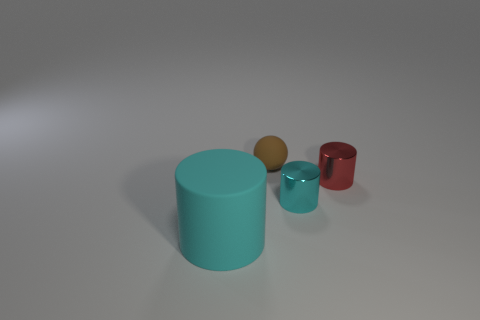Subtract all cyan cylinders. How many cylinders are left? 1 Subtract all red shiny cylinders. How many cylinders are left? 2 Subtract 0 purple cylinders. How many objects are left? 4 Subtract all cylinders. How many objects are left? 1 Subtract 3 cylinders. How many cylinders are left? 0 Subtract all cyan balls. Subtract all purple cylinders. How many balls are left? 1 Subtract all yellow cubes. How many red cylinders are left? 1 Subtract all large cyan matte balls. Subtract all tiny metal cylinders. How many objects are left? 2 Add 1 cylinders. How many cylinders are left? 4 Add 4 large cyan things. How many large cyan things exist? 5 